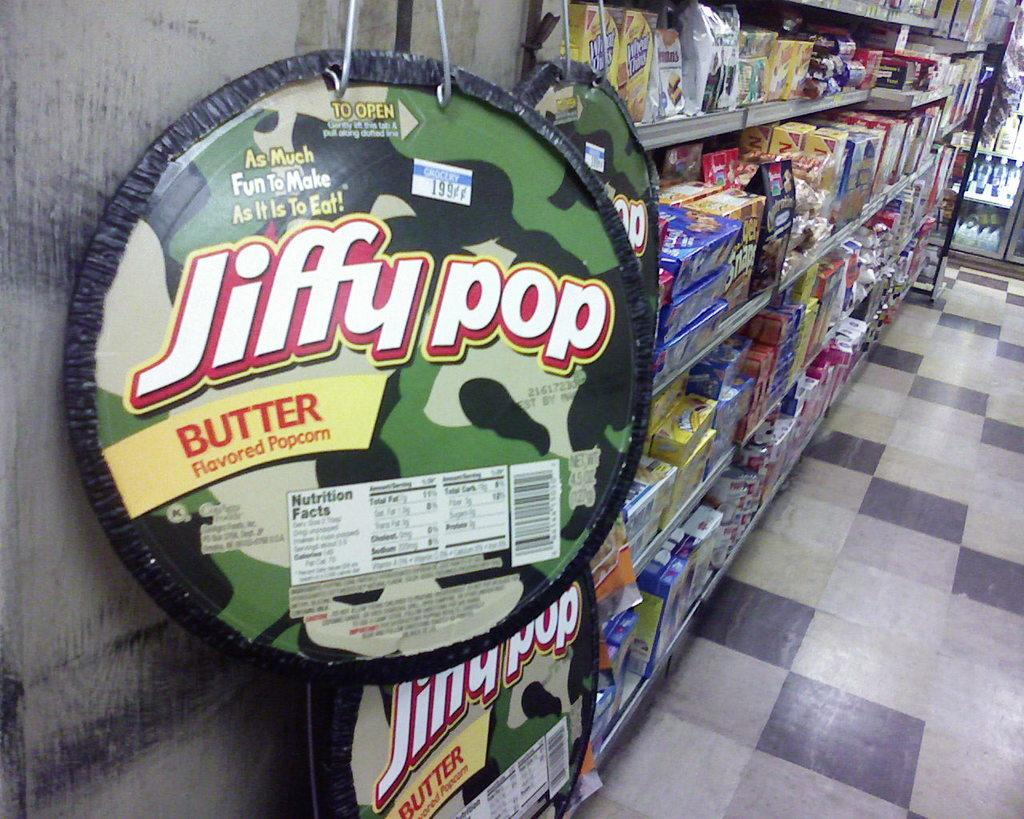<image>
Relay a brief, clear account of the picture shown. Jiffy pop popcorn kettle hanging next to an aisle of food. 